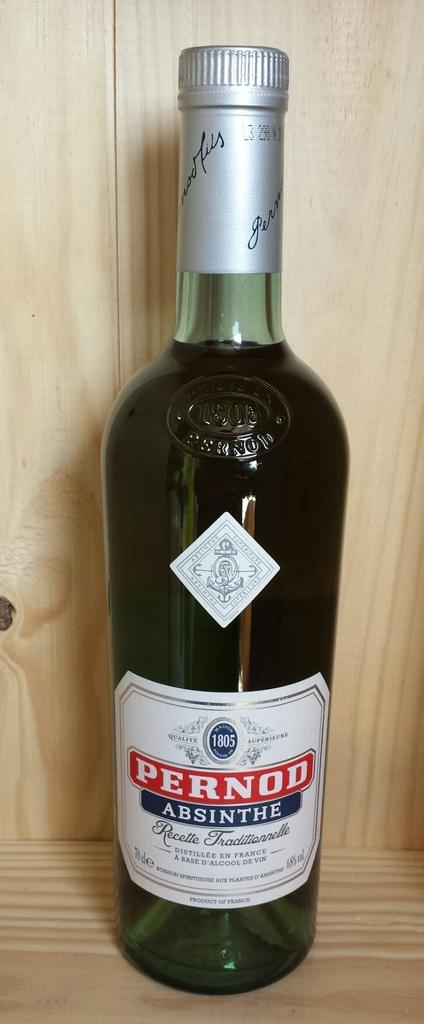<image>
Describe the image concisely. A bottle of Pernod Absinthe sits on a wooden shelf. 